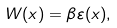Convert formula to latex. <formula><loc_0><loc_0><loc_500><loc_500>W ( x ) = \beta \varepsilon ( x ) ,</formula> 